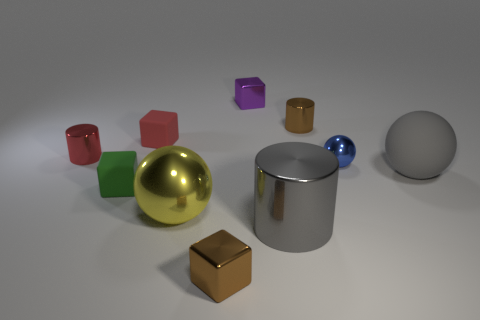Subtract all metallic spheres. How many spheres are left? 1 Subtract 2 spheres. How many spheres are left? 1 Subtract all green cubes. How many cubes are left? 3 Subtract all blocks. How many objects are left? 6 Subtract 1 red cylinders. How many objects are left? 9 Subtract all brown cubes. Subtract all green balls. How many cubes are left? 3 Subtract all gray blocks. How many gray balls are left? 1 Subtract all red metal objects. Subtract all yellow shiny spheres. How many objects are left? 8 Add 6 large metallic spheres. How many large metallic spheres are left? 7 Add 3 cylinders. How many cylinders exist? 6 